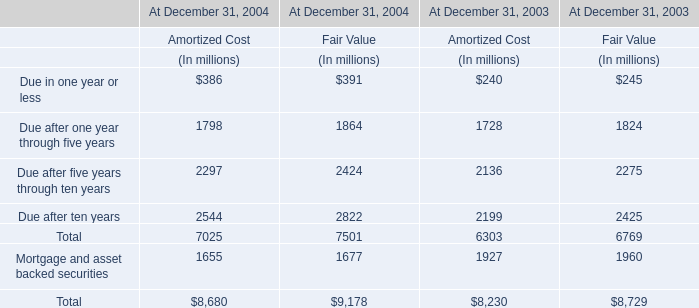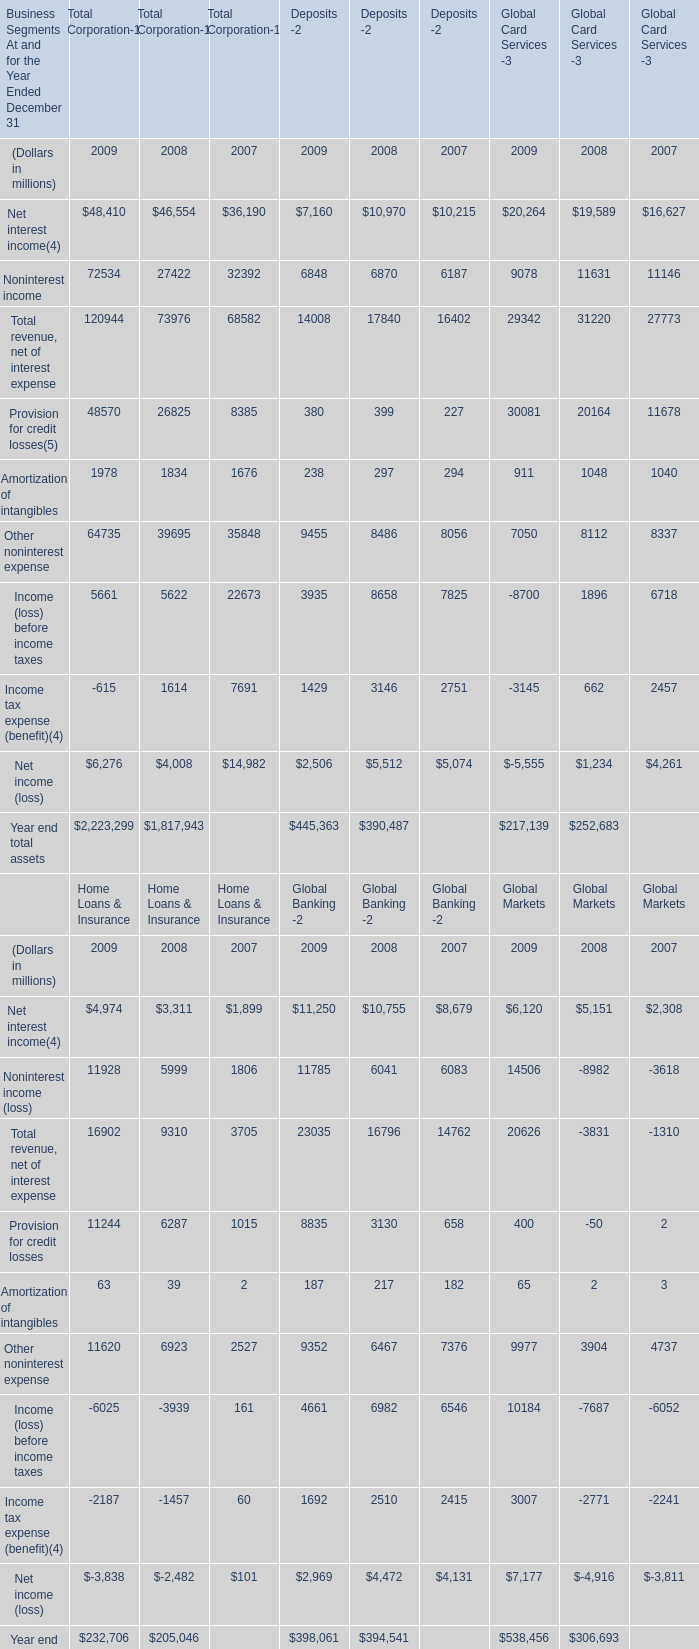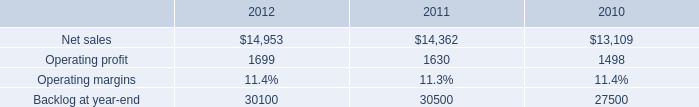what is the growth rate in operating profit for aeronautics in 2012? 
Computations: ((1699 - 1630) / 1630)
Answer: 0.04233. 